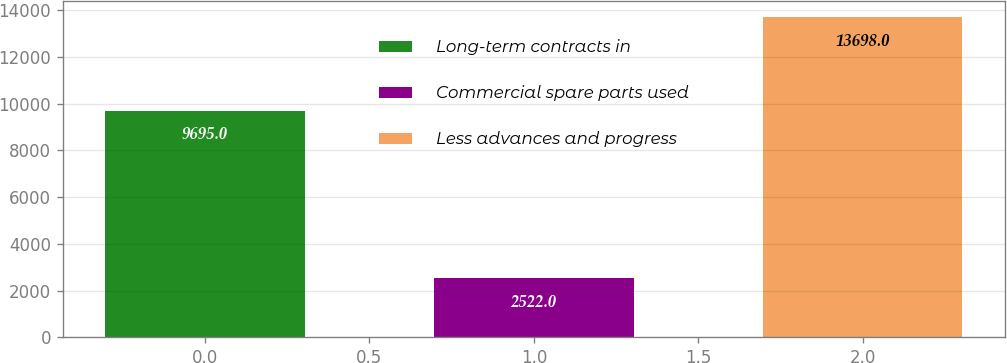Convert chart to OTSL. <chart><loc_0><loc_0><loc_500><loc_500><bar_chart><fcel>Long-term contracts in<fcel>Commercial spare parts used<fcel>Less advances and progress<nl><fcel>9695<fcel>2522<fcel>13698<nl></chart> 